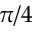<formula> <loc_0><loc_0><loc_500><loc_500>\pi / 4</formula> 